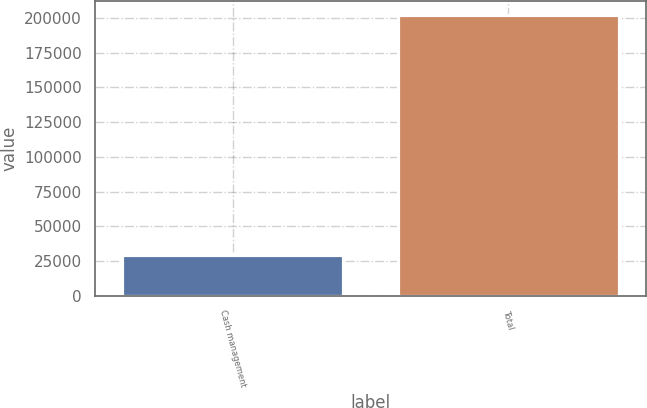Convert chart to OTSL. <chart><loc_0><loc_0><loc_500><loc_500><bar_chart><fcel>Cash management<fcel>Total<nl><fcel>29228<fcel>202191<nl></chart> 